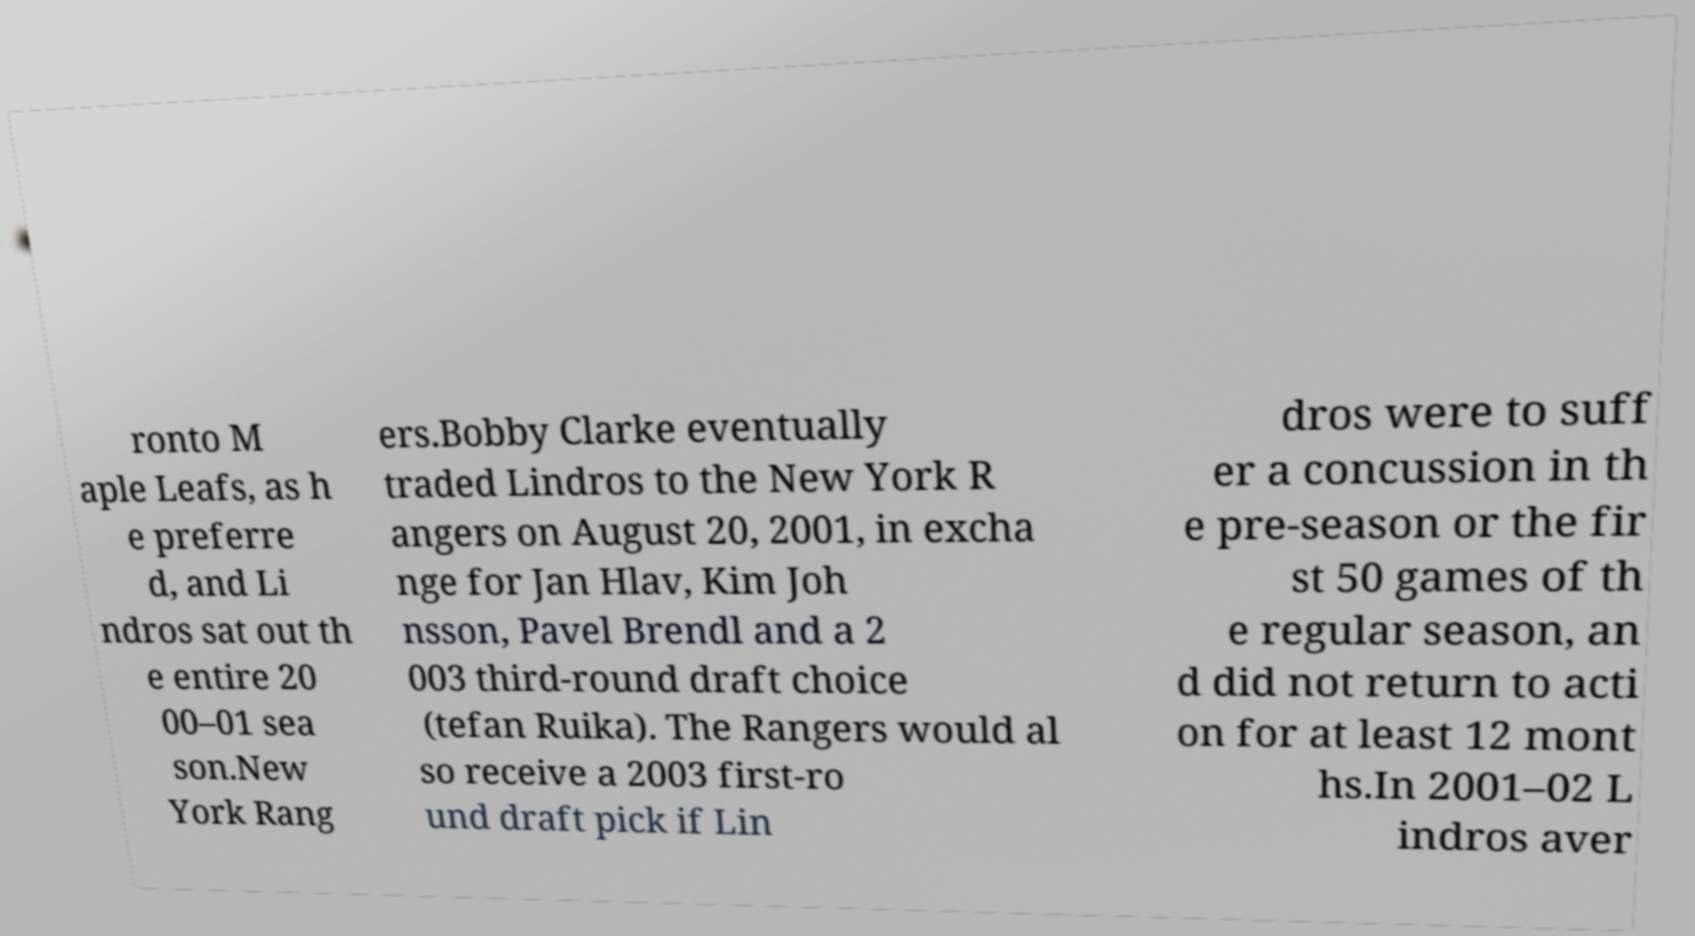Can you read and provide the text displayed in the image?This photo seems to have some interesting text. Can you extract and type it out for me? ronto M aple Leafs, as h e preferre d, and Li ndros sat out th e entire 20 00–01 sea son.New York Rang ers.Bobby Clarke eventually traded Lindros to the New York R angers on August 20, 2001, in excha nge for Jan Hlav, Kim Joh nsson, Pavel Brendl and a 2 003 third-round draft choice (tefan Ruika). The Rangers would al so receive a 2003 first-ro und draft pick if Lin dros were to suff er a concussion in th e pre-season or the fir st 50 games of th e regular season, an d did not return to acti on for at least 12 mont hs.In 2001–02 L indros aver 